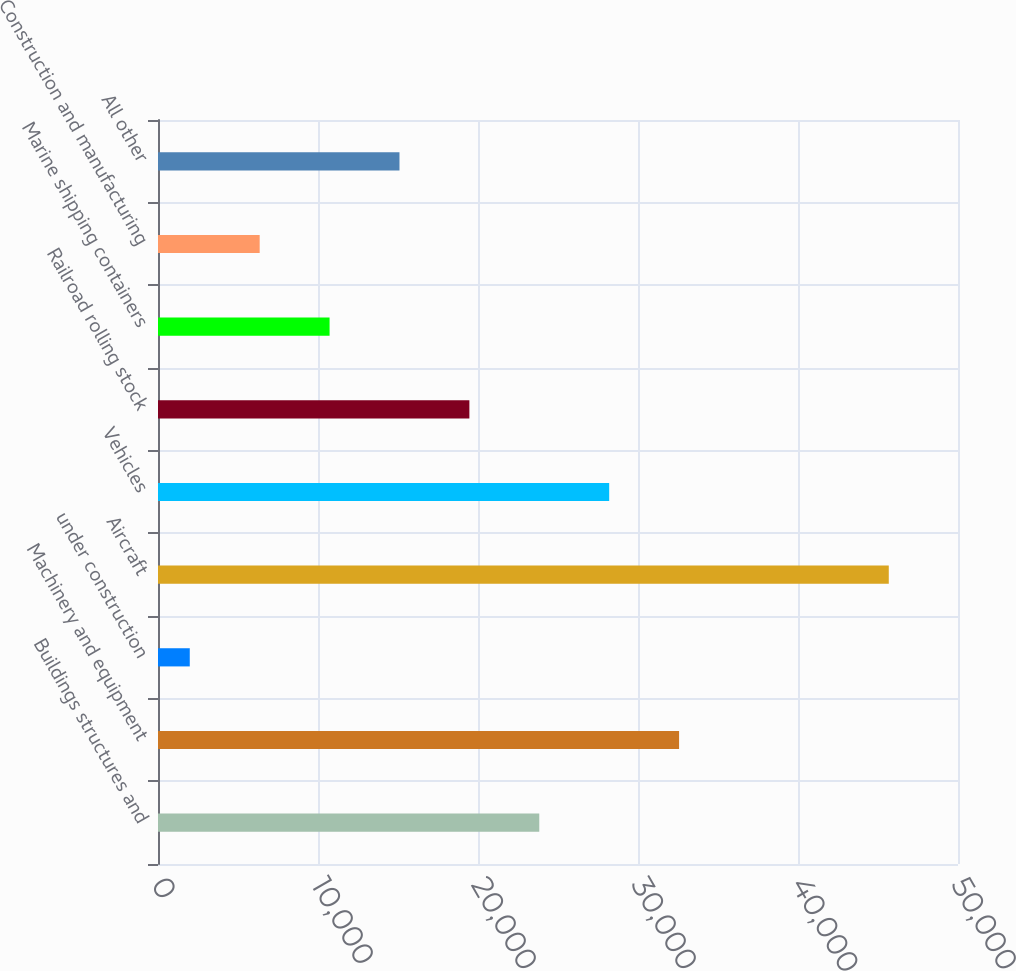Convert chart to OTSL. <chart><loc_0><loc_0><loc_500><loc_500><bar_chart><fcel>Buildings structures and<fcel>Machinery and equipment<fcel>under construction<fcel>Aircraft<fcel>Vehicles<fcel>Railroad rolling stock<fcel>Marine shipping containers<fcel>Construction and manufacturing<fcel>All other<nl><fcel>23830<fcel>32567.6<fcel>1986<fcel>45674<fcel>28198.8<fcel>19461.2<fcel>10723.6<fcel>6354.8<fcel>15092.4<nl></chart> 